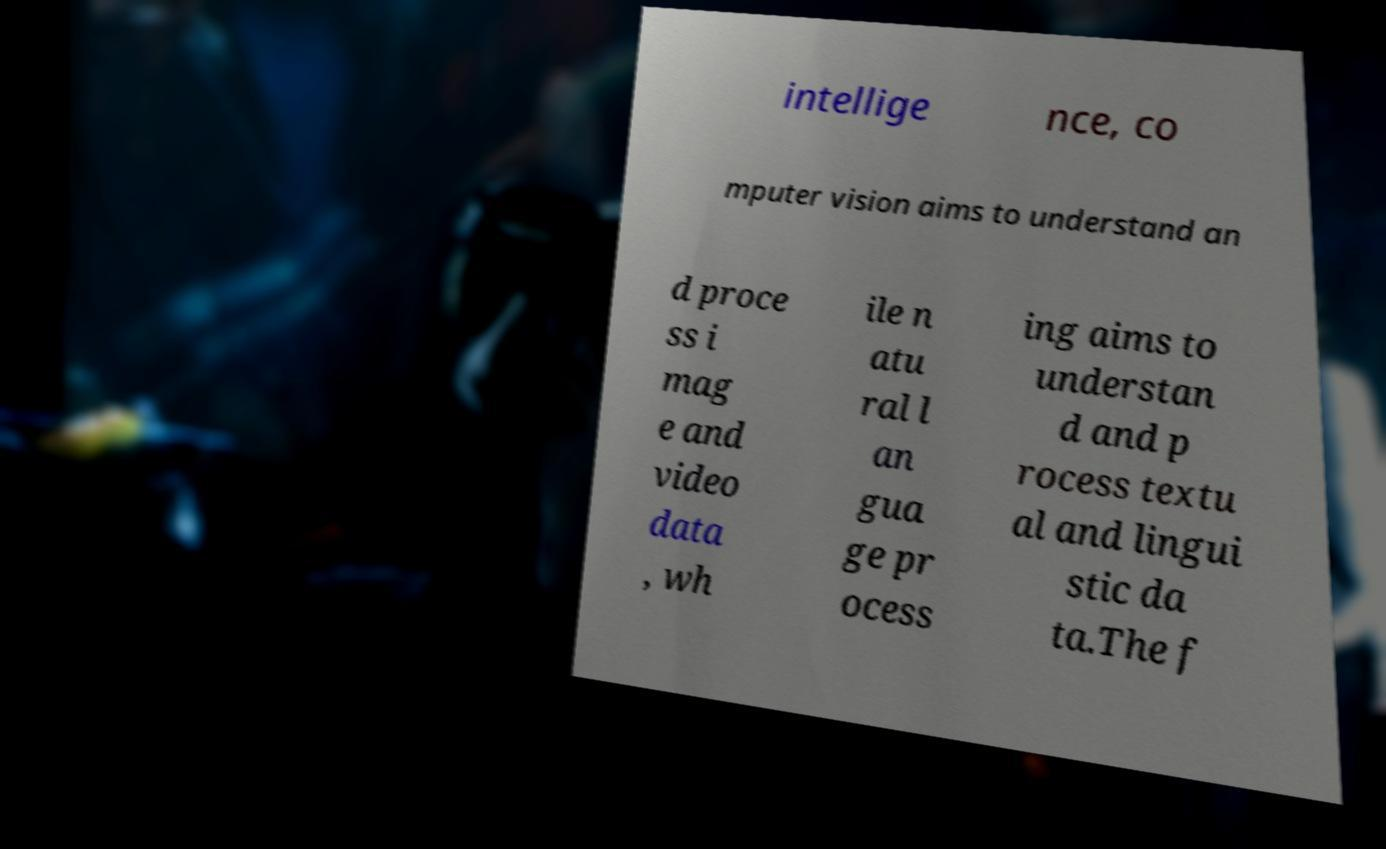I need the written content from this picture converted into text. Can you do that? intellige nce, co mputer vision aims to understand an d proce ss i mag e and video data , wh ile n atu ral l an gua ge pr ocess ing aims to understan d and p rocess textu al and lingui stic da ta.The f 